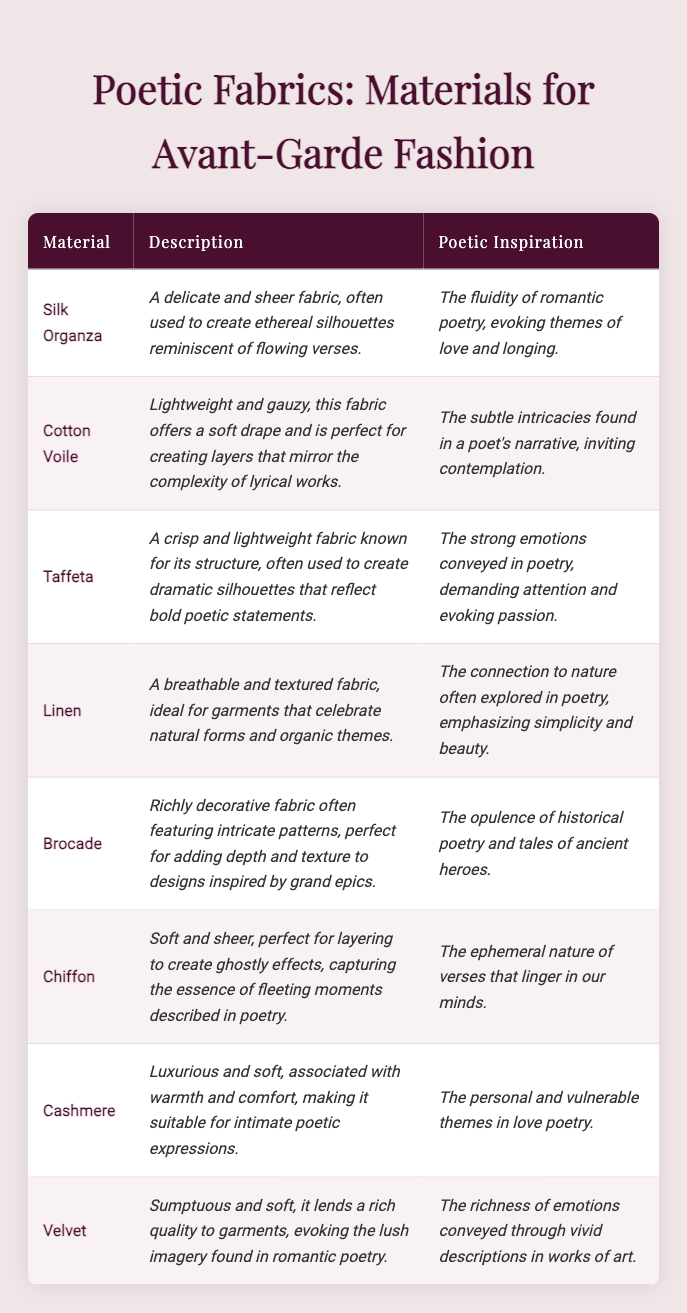What material is described as "a delicate and sheer fabric"? The table lists "Silk Organza" as the first material, and its description includes the phrase "a delicate and sheer fabric."
Answer: Silk Organza Which fabric is inspired by the "strong emotions conveyed in poetry"? According to the table, "Taffeta" is mentioned as being inspired by the "strong emotions conveyed in poetry."
Answer: Taffeta True or False: Cashmere is associated with warmth and comfort. The description for Cashmere in the table confirms it is "associated with warmth and comfort," making the statement true.
Answer: True What are the two materials that evoke nature and simplicity in their inspirations? The table indicates that "Linen" is connected to nature and emphasizes simplicity, while "Cashmere" reflects personal and intimate themes rather than nature. Therefore, only "Linen" fits the criteria.
Answer: Linen Name a fabric that captures the essence of fleeting moments in poetry. The table mentions "Chiffon" as the fabric that captures the essence of fleeting moments described in poetry.
Answer: Chiffon Which material is defined as "perfect for adding depth and texture to designs inspired by grand epics"? The table describes "Brocade" as "perfect for adding depth and texture to designs inspired by grand epics.”
Answer: Brocade Which two fabrics are characterized as lightweight? The table lists "Cotton Voile" and "Chiffon" as lightweight fabrics, based on their respective descriptions mentioning "lightweight" and "soft and sheer."
Answer: Cotton Voile, Chiffon List all materials that are associated with romantic poetry. The table names "Silk Organza" and "Velvet" under the context of romantic poetry, focusing on themes of love and lush imagery. Therefore, these two materials can be categorized here.
Answer: Silk Organza, Velvet How many materials are linked to nature or natural themes? The table includes "Linen" as material directly associated with nature, but "Cashmere" also has a soft and intimate quality rather than natural origins. Thus, only Linen reflects nature themes.
Answer: 1 What is the primary theme of the fabric inspired by romantic poetry? The table mentions "Silk Organza" is inspired by the fluidity of romantic poetry, evoking themes of love and longing. This reflects the primary theme associated with this fabric.
Answer: Love and longing 